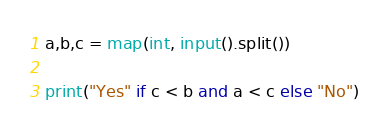Convert code to text. <code><loc_0><loc_0><loc_500><loc_500><_Python_>a,b,c = map(int, input().split())

print("Yes" if c < b and a < c else "No")</code> 